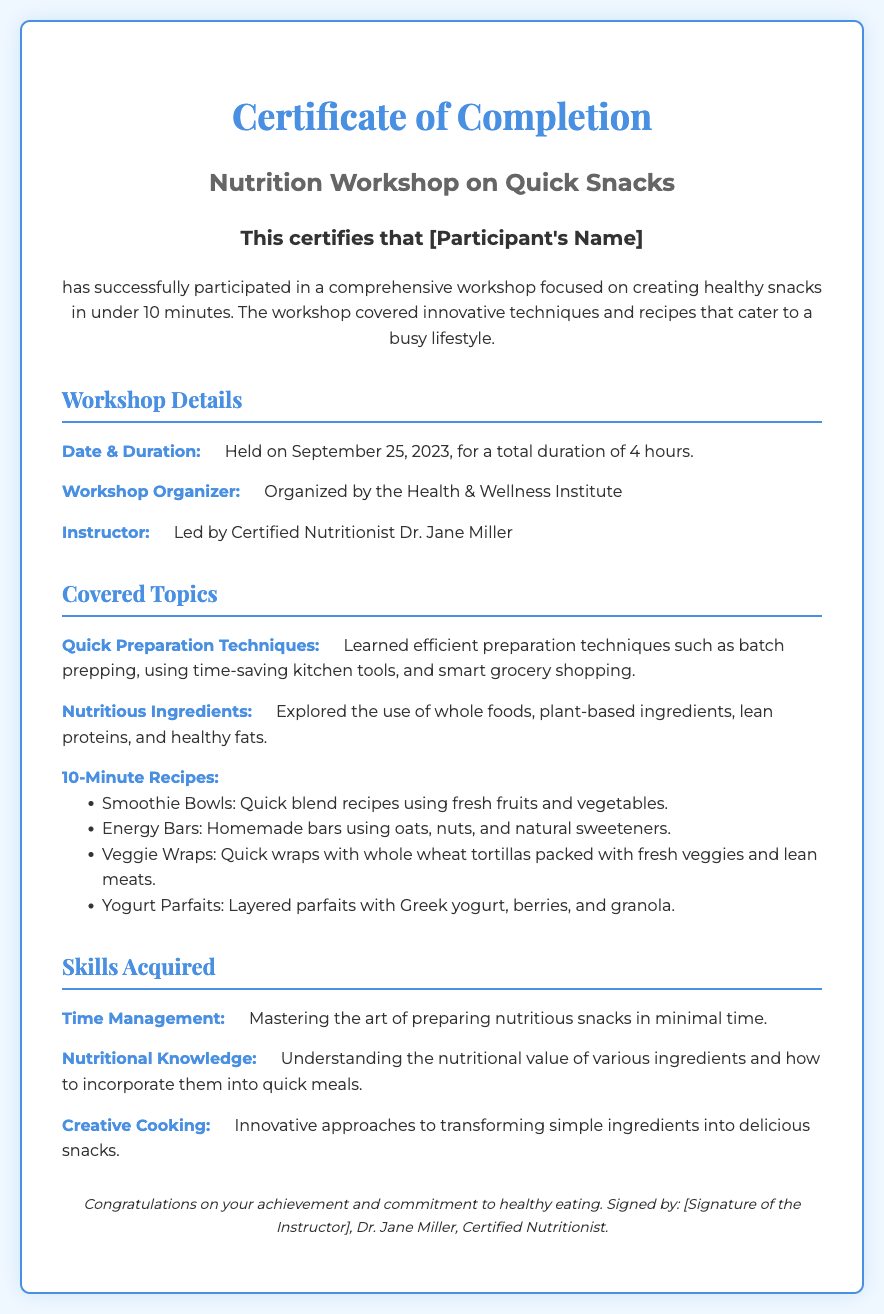What is the title of the workshop? The title is specifically mentioned at the top of the certificate, indicating the focus of the program.
Answer: Nutrition Workshop on Quick Snacks Who organized the workshop? The organizer is clearly stated in the document under the workshop details section.
Answer: Health & Wellness Institute What date was the workshop held? The date is provided in the workshop details section, clearly indicating when it occurred.
Answer: September 25, 2023 How long was the workshop's duration? The duration is noted in the workshop details section as part of the workshop information.
Answer: 4 hours Which instructor led the workshop? The name of the instructor is mentioned under the workshop details.
Answer: Dr. Jane Miller What skill related to cooking was acquired? The document lists several skills, and one of them pertains to cooking techniques learned in the workshop.
Answer: Creative Cooking What type of recipes were covered in the workshop? The workshop details include a specific list of recipe types in the content covered section.
Answer: 10-Minute Recipes What ingredient types were explored? The document specifically mentions the types of ingredients that were covered in the workshop related to nutrition.
Answer: Whole foods, plant-based ingredients, lean proteins, and healthy fats What type of certification is this document? The document denotes a specific achievement in relation to a completed program or workshop.
Answer: Certificate of Completion 